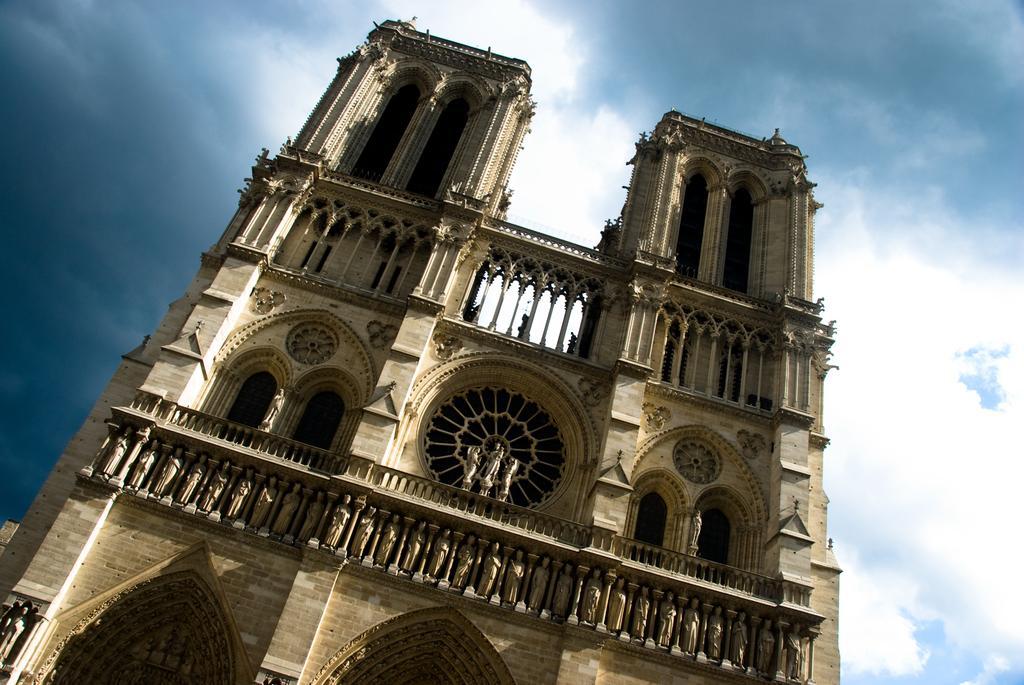Describe this image in one or two sentences. We can see building and we can see statues and windows. In the background we can see sky with clouds. 